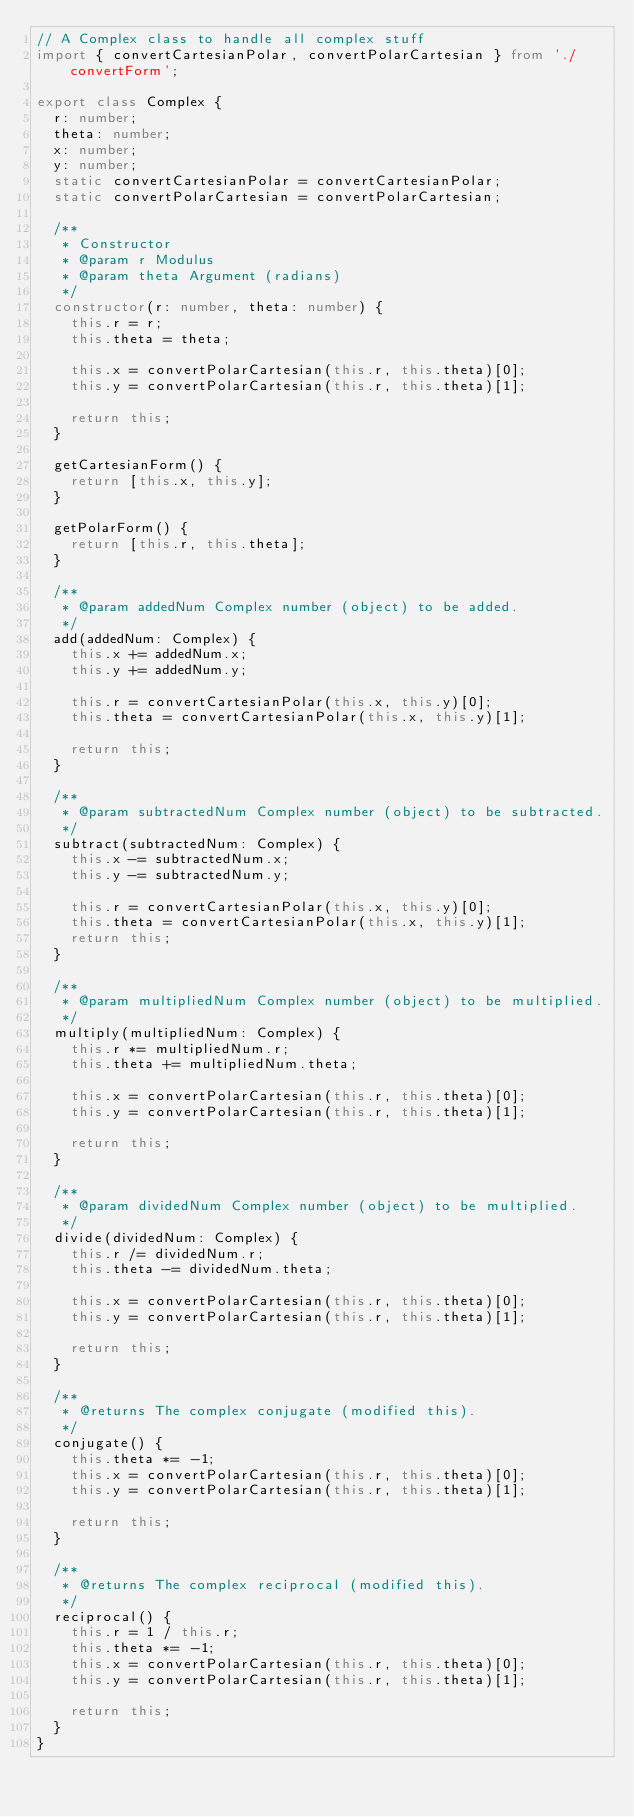Convert code to text. <code><loc_0><loc_0><loc_500><loc_500><_TypeScript_>// A Complex class to handle all complex stuff
import { convertCartesianPolar, convertPolarCartesian } from './convertForm';

export class Complex {
  r: number;
  theta: number;
  x: number;
  y: number;
  static convertCartesianPolar = convertCartesianPolar;
  static convertPolarCartesian = convertPolarCartesian;

  /**
   * Constructor
   * @param r Modulus
   * @param theta Argument (radians)
   */
  constructor(r: number, theta: number) {
    this.r = r;
    this.theta = theta;

    this.x = convertPolarCartesian(this.r, this.theta)[0];
    this.y = convertPolarCartesian(this.r, this.theta)[1];

    return this;
  }

  getCartesianForm() {
    return [this.x, this.y];
  }

  getPolarForm() {
    return [this.r, this.theta];
  }

  /**
   * @param addedNum Complex number (object) to be added.
   */
  add(addedNum: Complex) {
    this.x += addedNum.x;
    this.y += addedNum.y;

    this.r = convertCartesianPolar(this.x, this.y)[0];
    this.theta = convertCartesianPolar(this.x, this.y)[1];

    return this;
  }

  /**
   * @param subtractedNum Complex number (object) to be subtracted.
   */
  subtract(subtractedNum: Complex) {
    this.x -= subtractedNum.x;
    this.y -= subtractedNum.y;

    this.r = convertCartesianPolar(this.x, this.y)[0];
    this.theta = convertCartesianPolar(this.x, this.y)[1];
    return this;
  }

  /**
   * @param multipliedNum Complex number (object) to be multiplied.
   */
  multiply(multipliedNum: Complex) {
    this.r *= multipliedNum.r;
    this.theta += multipliedNum.theta;

    this.x = convertPolarCartesian(this.r, this.theta)[0];
    this.y = convertPolarCartesian(this.r, this.theta)[1];

    return this;
  }

  /**
   * @param dividedNum Complex number (object) to be multiplied.
   */
  divide(dividedNum: Complex) {
    this.r /= dividedNum.r;
    this.theta -= dividedNum.theta;

    this.x = convertPolarCartesian(this.r, this.theta)[0];
    this.y = convertPolarCartesian(this.r, this.theta)[1];

    return this;
  }

  /**
   * @returns The complex conjugate (modified this).
   */
  conjugate() {
    this.theta *= -1;
    this.x = convertPolarCartesian(this.r, this.theta)[0];
    this.y = convertPolarCartesian(this.r, this.theta)[1];

    return this;
  }

  /**
   * @returns The complex reciprocal (modified this).
   */
  reciprocal() {
    this.r = 1 / this.r;
    this.theta *= -1;
    this.x = convertPolarCartesian(this.r, this.theta)[0];
    this.y = convertPolarCartesian(this.r, this.theta)[1];

    return this;
  }
}
</code> 